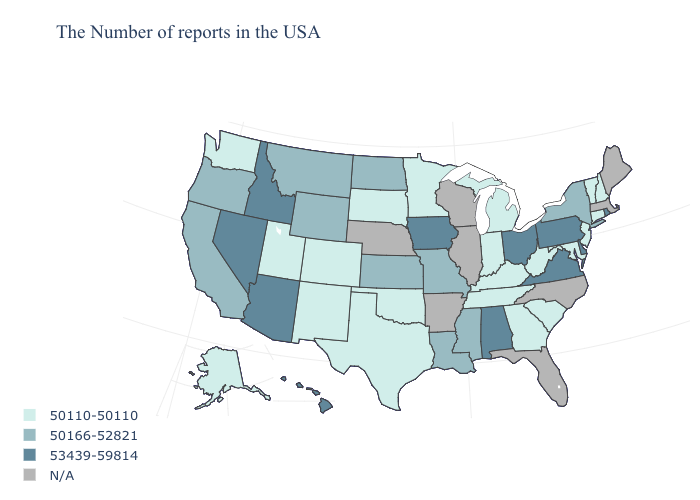Name the states that have a value in the range 50110-50110?
Short answer required. New Hampshire, Vermont, Connecticut, New Jersey, Maryland, South Carolina, West Virginia, Georgia, Michigan, Kentucky, Indiana, Tennessee, Minnesota, Oklahoma, Texas, South Dakota, Colorado, New Mexico, Utah, Washington, Alaska. What is the value of Texas?
Concise answer only. 50110-50110. What is the value of Vermont?
Concise answer only. 50110-50110. Name the states that have a value in the range 50110-50110?
Short answer required. New Hampshire, Vermont, Connecticut, New Jersey, Maryland, South Carolina, West Virginia, Georgia, Michigan, Kentucky, Indiana, Tennessee, Minnesota, Oklahoma, Texas, South Dakota, Colorado, New Mexico, Utah, Washington, Alaska. Name the states that have a value in the range 53439-59814?
Answer briefly. Rhode Island, Delaware, Pennsylvania, Virginia, Ohio, Alabama, Iowa, Arizona, Idaho, Nevada, Hawaii. Name the states that have a value in the range 53439-59814?
Give a very brief answer. Rhode Island, Delaware, Pennsylvania, Virginia, Ohio, Alabama, Iowa, Arizona, Idaho, Nevada, Hawaii. Does Alaska have the lowest value in the USA?
Concise answer only. Yes. Name the states that have a value in the range 53439-59814?
Concise answer only. Rhode Island, Delaware, Pennsylvania, Virginia, Ohio, Alabama, Iowa, Arizona, Idaho, Nevada, Hawaii. Does Alaska have the lowest value in the West?
Give a very brief answer. Yes. Does Alaska have the highest value in the West?
Short answer required. No. How many symbols are there in the legend?
Quick response, please. 4. Which states have the lowest value in the West?
Be succinct. Colorado, New Mexico, Utah, Washington, Alaska. Does the first symbol in the legend represent the smallest category?
Concise answer only. Yes. 